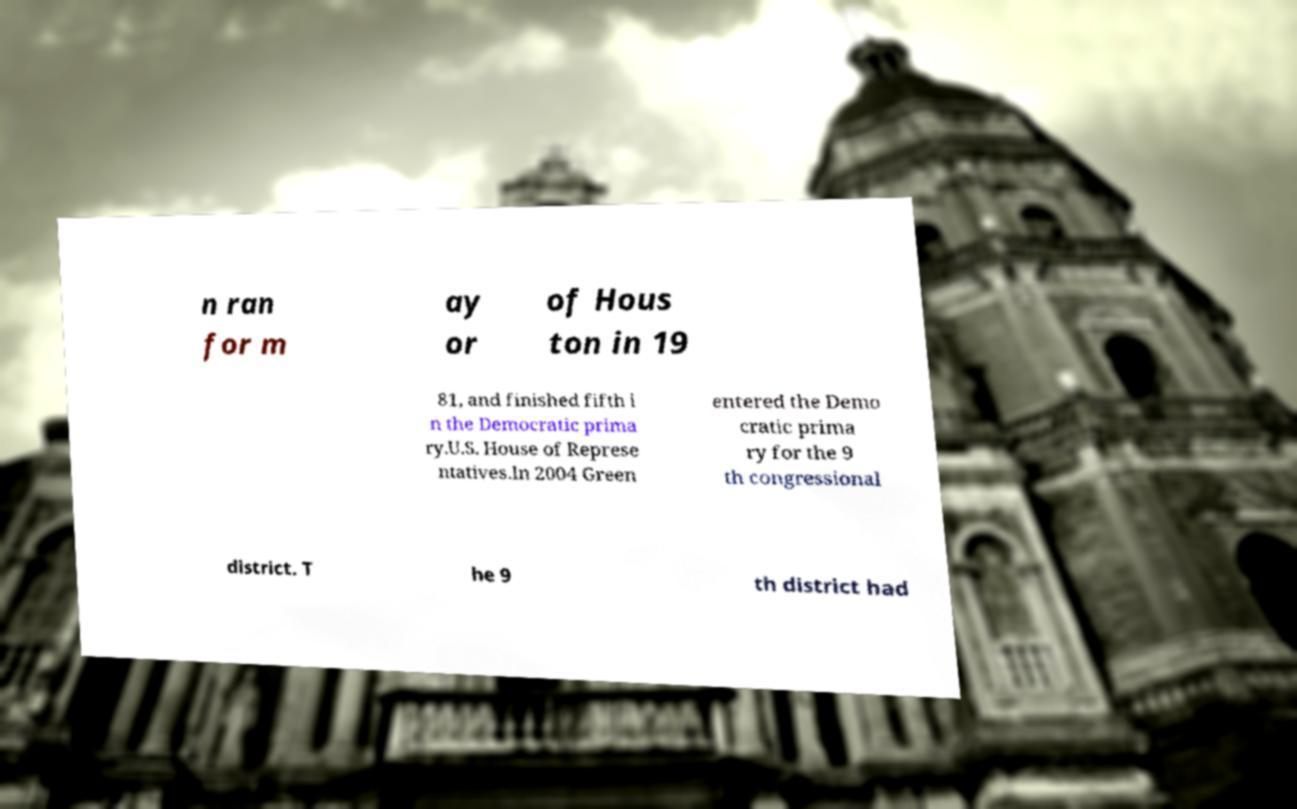Please identify and transcribe the text found in this image. n ran for m ay or of Hous ton in 19 81, and finished fifth i n the Democratic prima ry.U.S. House of Represe ntatives.In 2004 Green entered the Demo cratic prima ry for the 9 th congressional district. T he 9 th district had 